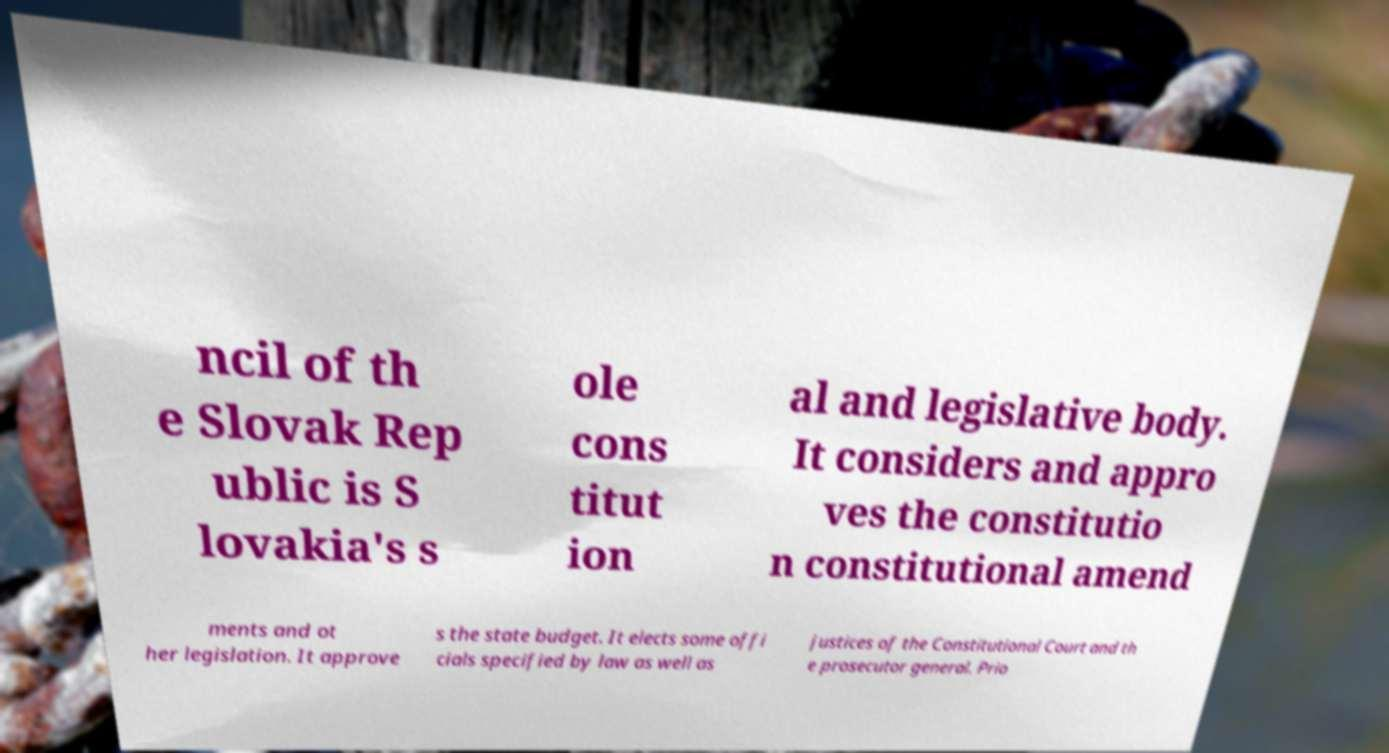For documentation purposes, I need the text within this image transcribed. Could you provide that? ncil of th e Slovak Rep ublic is S lovakia's s ole cons titut ion al and legislative body. It considers and appro ves the constitutio n constitutional amend ments and ot her legislation. It approve s the state budget. It elects some offi cials specified by law as well as justices of the Constitutional Court and th e prosecutor general. Prio 